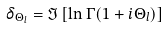Convert formula to latex. <formula><loc_0><loc_0><loc_500><loc_500>\delta _ { \Theta _ { l } } = \Im \left [ \ln \Gamma ( 1 + i \Theta _ { l } ) \right ] \,</formula> 